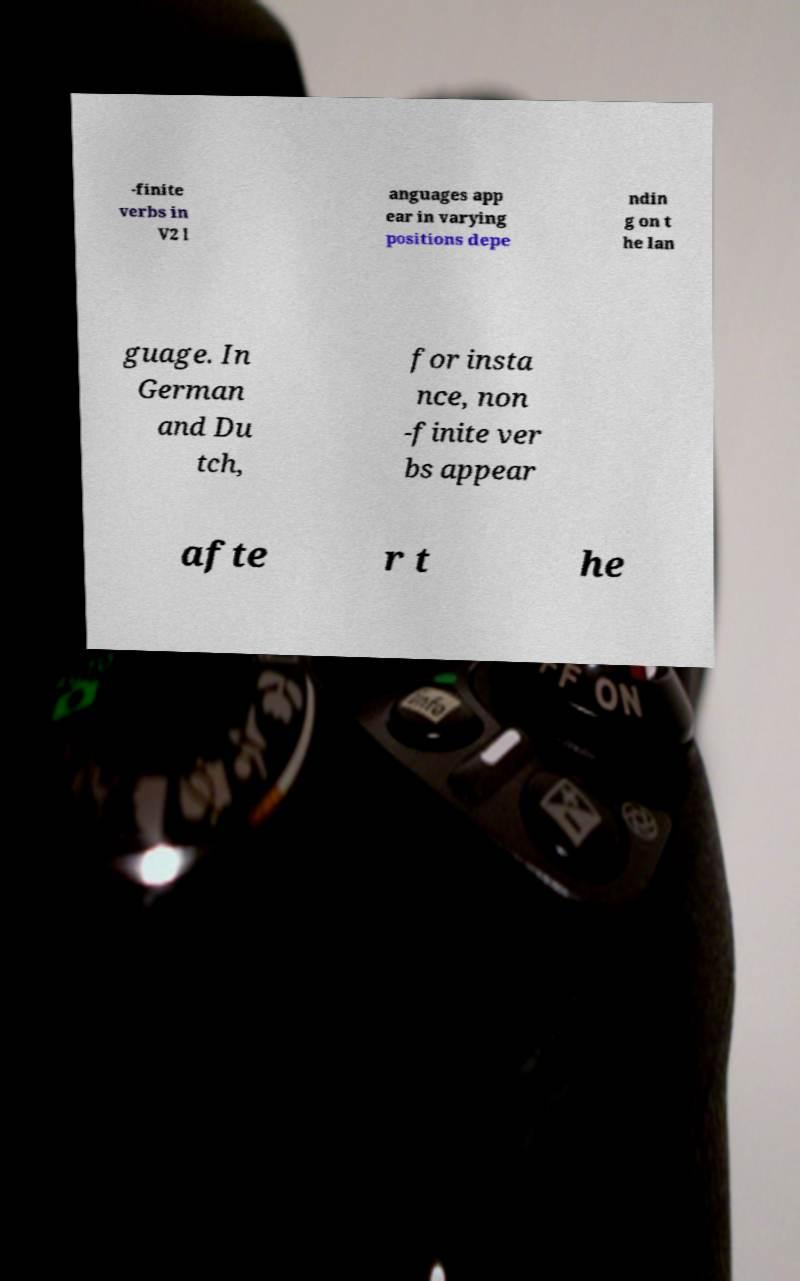Please identify and transcribe the text found in this image. -finite verbs in V2 l anguages app ear in varying positions depe ndin g on t he lan guage. In German and Du tch, for insta nce, non -finite ver bs appear afte r t he 